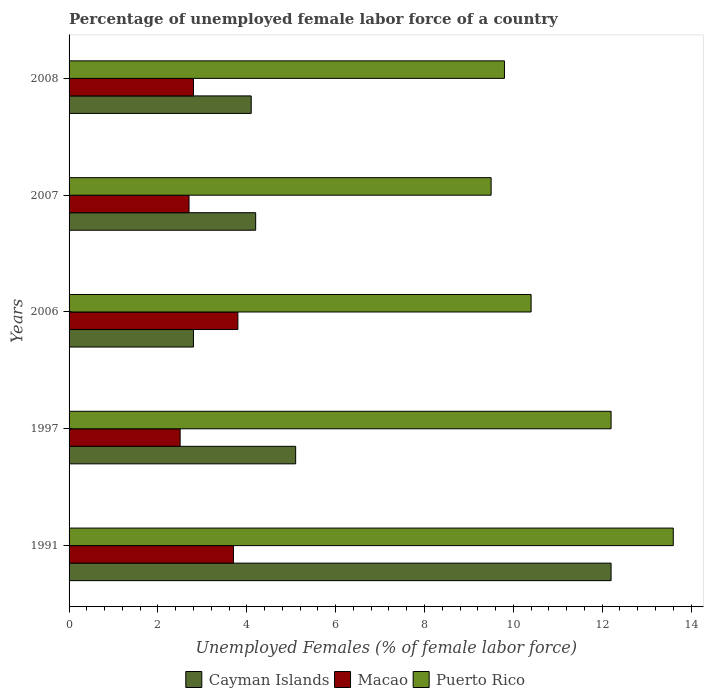How many different coloured bars are there?
Offer a very short reply. 3. How many groups of bars are there?
Offer a terse response. 5. Are the number of bars on each tick of the Y-axis equal?
Your answer should be very brief. Yes. How many bars are there on the 2nd tick from the top?
Offer a terse response. 3. What is the label of the 4th group of bars from the top?
Ensure brevity in your answer.  1997. What is the percentage of unemployed female labor force in Macao in 1991?
Offer a terse response. 3.7. Across all years, what is the maximum percentage of unemployed female labor force in Puerto Rico?
Offer a very short reply. 13.6. In which year was the percentage of unemployed female labor force in Macao minimum?
Give a very brief answer. 1997. What is the difference between the percentage of unemployed female labor force in Macao in 1997 and that in 2006?
Keep it short and to the point. -1.3. What is the difference between the percentage of unemployed female labor force in Macao in 2006 and the percentage of unemployed female labor force in Puerto Rico in 2007?
Ensure brevity in your answer.  -5.7. In the year 2006, what is the difference between the percentage of unemployed female labor force in Puerto Rico and percentage of unemployed female labor force in Cayman Islands?
Make the answer very short. 7.6. What is the ratio of the percentage of unemployed female labor force in Cayman Islands in 1991 to that in 2008?
Ensure brevity in your answer.  2.98. Is the percentage of unemployed female labor force in Cayman Islands in 1991 less than that in 2006?
Keep it short and to the point. No. Is the difference between the percentage of unemployed female labor force in Puerto Rico in 1997 and 2007 greater than the difference between the percentage of unemployed female labor force in Cayman Islands in 1997 and 2007?
Your answer should be compact. Yes. What is the difference between the highest and the second highest percentage of unemployed female labor force in Cayman Islands?
Your answer should be compact. 7.1. What is the difference between the highest and the lowest percentage of unemployed female labor force in Puerto Rico?
Give a very brief answer. 4.1. In how many years, is the percentage of unemployed female labor force in Macao greater than the average percentage of unemployed female labor force in Macao taken over all years?
Ensure brevity in your answer.  2. What does the 3rd bar from the top in 2006 represents?
Your answer should be compact. Cayman Islands. What does the 2nd bar from the bottom in 2008 represents?
Ensure brevity in your answer.  Macao. How many bars are there?
Your response must be concise. 15. Are all the bars in the graph horizontal?
Offer a very short reply. Yes. What is the difference between two consecutive major ticks on the X-axis?
Give a very brief answer. 2. Does the graph contain grids?
Give a very brief answer. No. How many legend labels are there?
Your response must be concise. 3. What is the title of the graph?
Ensure brevity in your answer.  Percentage of unemployed female labor force of a country. What is the label or title of the X-axis?
Offer a very short reply. Unemployed Females (% of female labor force). What is the Unemployed Females (% of female labor force) of Cayman Islands in 1991?
Provide a short and direct response. 12.2. What is the Unemployed Females (% of female labor force) of Macao in 1991?
Give a very brief answer. 3.7. What is the Unemployed Females (% of female labor force) of Puerto Rico in 1991?
Ensure brevity in your answer.  13.6. What is the Unemployed Females (% of female labor force) of Cayman Islands in 1997?
Your response must be concise. 5.1. What is the Unemployed Females (% of female labor force) in Puerto Rico in 1997?
Make the answer very short. 12.2. What is the Unemployed Females (% of female labor force) of Cayman Islands in 2006?
Keep it short and to the point. 2.8. What is the Unemployed Females (% of female labor force) of Macao in 2006?
Provide a succinct answer. 3.8. What is the Unemployed Females (% of female labor force) of Puerto Rico in 2006?
Keep it short and to the point. 10.4. What is the Unemployed Females (% of female labor force) of Cayman Islands in 2007?
Give a very brief answer. 4.2. What is the Unemployed Females (% of female labor force) in Macao in 2007?
Provide a short and direct response. 2.7. What is the Unemployed Females (% of female labor force) of Puerto Rico in 2007?
Make the answer very short. 9.5. What is the Unemployed Females (% of female labor force) in Cayman Islands in 2008?
Provide a short and direct response. 4.1. What is the Unemployed Females (% of female labor force) of Macao in 2008?
Give a very brief answer. 2.8. What is the Unemployed Females (% of female labor force) of Puerto Rico in 2008?
Keep it short and to the point. 9.8. Across all years, what is the maximum Unemployed Females (% of female labor force) of Cayman Islands?
Your response must be concise. 12.2. Across all years, what is the maximum Unemployed Females (% of female labor force) of Macao?
Your answer should be compact. 3.8. Across all years, what is the maximum Unemployed Females (% of female labor force) in Puerto Rico?
Provide a succinct answer. 13.6. Across all years, what is the minimum Unemployed Females (% of female labor force) of Cayman Islands?
Ensure brevity in your answer.  2.8. What is the total Unemployed Females (% of female labor force) of Cayman Islands in the graph?
Offer a very short reply. 28.4. What is the total Unemployed Females (% of female labor force) of Macao in the graph?
Your answer should be compact. 15.5. What is the total Unemployed Females (% of female labor force) in Puerto Rico in the graph?
Provide a short and direct response. 55.5. What is the difference between the Unemployed Females (% of female labor force) of Macao in 1991 and that in 1997?
Your response must be concise. 1.2. What is the difference between the Unemployed Females (% of female labor force) of Macao in 1991 and that in 2006?
Provide a short and direct response. -0.1. What is the difference between the Unemployed Females (% of female labor force) of Macao in 1991 and that in 2007?
Your answer should be very brief. 1. What is the difference between the Unemployed Females (% of female labor force) of Macao in 1991 and that in 2008?
Ensure brevity in your answer.  0.9. What is the difference between the Unemployed Females (% of female labor force) in Cayman Islands in 1997 and that in 2006?
Make the answer very short. 2.3. What is the difference between the Unemployed Females (% of female labor force) in Macao in 1997 and that in 2006?
Your response must be concise. -1.3. What is the difference between the Unemployed Females (% of female labor force) in Macao in 1997 and that in 2007?
Your answer should be compact. -0.2. What is the difference between the Unemployed Females (% of female labor force) of Cayman Islands in 1997 and that in 2008?
Make the answer very short. 1. What is the difference between the Unemployed Females (% of female labor force) in Macao in 1997 and that in 2008?
Make the answer very short. -0.3. What is the difference between the Unemployed Females (% of female labor force) in Macao in 2006 and that in 2007?
Give a very brief answer. 1.1. What is the difference between the Unemployed Females (% of female labor force) of Puerto Rico in 2006 and that in 2008?
Make the answer very short. 0.6. What is the difference between the Unemployed Females (% of female labor force) in Macao in 2007 and that in 2008?
Offer a very short reply. -0.1. What is the difference between the Unemployed Females (% of female labor force) of Puerto Rico in 2007 and that in 2008?
Your response must be concise. -0.3. What is the difference between the Unemployed Females (% of female labor force) in Cayman Islands in 1991 and the Unemployed Females (% of female labor force) in Macao in 1997?
Your answer should be compact. 9.7. What is the difference between the Unemployed Females (% of female labor force) in Cayman Islands in 1991 and the Unemployed Females (% of female labor force) in Puerto Rico in 1997?
Keep it short and to the point. 0. What is the difference between the Unemployed Females (% of female labor force) in Macao in 1991 and the Unemployed Females (% of female labor force) in Puerto Rico in 1997?
Ensure brevity in your answer.  -8.5. What is the difference between the Unemployed Females (% of female labor force) in Cayman Islands in 1991 and the Unemployed Females (% of female labor force) in Puerto Rico in 2006?
Keep it short and to the point. 1.8. What is the difference between the Unemployed Females (% of female labor force) in Cayman Islands in 1991 and the Unemployed Females (% of female labor force) in Macao in 2007?
Ensure brevity in your answer.  9.5. What is the difference between the Unemployed Females (% of female labor force) of Cayman Islands in 1991 and the Unemployed Females (% of female labor force) of Puerto Rico in 2007?
Make the answer very short. 2.7. What is the difference between the Unemployed Females (% of female labor force) in Macao in 1991 and the Unemployed Females (% of female labor force) in Puerto Rico in 2007?
Keep it short and to the point. -5.8. What is the difference between the Unemployed Females (% of female labor force) of Macao in 1997 and the Unemployed Females (% of female labor force) of Puerto Rico in 2008?
Keep it short and to the point. -7.3. What is the difference between the Unemployed Females (% of female labor force) in Cayman Islands in 2006 and the Unemployed Females (% of female labor force) in Macao in 2007?
Provide a short and direct response. 0.1. What is the difference between the Unemployed Females (% of female labor force) in Cayman Islands in 2006 and the Unemployed Females (% of female labor force) in Puerto Rico in 2008?
Make the answer very short. -7. What is the difference between the Unemployed Females (% of female labor force) in Cayman Islands in 2007 and the Unemployed Females (% of female labor force) in Macao in 2008?
Give a very brief answer. 1.4. What is the difference between the Unemployed Females (% of female labor force) in Cayman Islands in 2007 and the Unemployed Females (% of female labor force) in Puerto Rico in 2008?
Keep it short and to the point. -5.6. What is the difference between the Unemployed Females (% of female labor force) of Macao in 2007 and the Unemployed Females (% of female labor force) of Puerto Rico in 2008?
Your response must be concise. -7.1. What is the average Unemployed Females (% of female labor force) of Cayman Islands per year?
Keep it short and to the point. 5.68. What is the average Unemployed Females (% of female labor force) in Macao per year?
Offer a very short reply. 3.1. What is the average Unemployed Females (% of female labor force) of Puerto Rico per year?
Provide a short and direct response. 11.1. In the year 1991, what is the difference between the Unemployed Females (% of female labor force) in Cayman Islands and Unemployed Females (% of female labor force) in Puerto Rico?
Offer a terse response. -1.4. In the year 1997, what is the difference between the Unemployed Females (% of female labor force) in Cayman Islands and Unemployed Females (% of female labor force) in Puerto Rico?
Provide a short and direct response. -7.1. In the year 1997, what is the difference between the Unemployed Females (% of female labor force) in Macao and Unemployed Females (% of female labor force) in Puerto Rico?
Your answer should be compact. -9.7. In the year 2006, what is the difference between the Unemployed Females (% of female labor force) in Cayman Islands and Unemployed Females (% of female labor force) in Macao?
Ensure brevity in your answer.  -1. In the year 2006, what is the difference between the Unemployed Females (% of female labor force) of Cayman Islands and Unemployed Females (% of female labor force) of Puerto Rico?
Make the answer very short. -7.6. In the year 2007, what is the difference between the Unemployed Females (% of female labor force) in Macao and Unemployed Females (% of female labor force) in Puerto Rico?
Ensure brevity in your answer.  -6.8. What is the ratio of the Unemployed Females (% of female labor force) in Cayman Islands in 1991 to that in 1997?
Provide a succinct answer. 2.39. What is the ratio of the Unemployed Females (% of female labor force) of Macao in 1991 to that in 1997?
Your answer should be compact. 1.48. What is the ratio of the Unemployed Females (% of female labor force) of Puerto Rico in 1991 to that in 1997?
Offer a very short reply. 1.11. What is the ratio of the Unemployed Females (% of female labor force) in Cayman Islands in 1991 to that in 2006?
Your answer should be very brief. 4.36. What is the ratio of the Unemployed Females (% of female labor force) in Macao in 1991 to that in 2006?
Offer a very short reply. 0.97. What is the ratio of the Unemployed Females (% of female labor force) of Puerto Rico in 1991 to that in 2006?
Offer a terse response. 1.31. What is the ratio of the Unemployed Females (% of female labor force) of Cayman Islands in 1991 to that in 2007?
Offer a terse response. 2.9. What is the ratio of the Unemployed Females (% of female labor force) of Macao in 1991 to that in 2007?
Provide a short and direct response. 1.37. What is the ratio of the Unemployed Females (% of female labor force) in Puerto Rico in 1991 to that in 2007?
Make the answer very short. 1.43. What is the ratio of the Unemployed Females (% of female labor force) in Cayman Islands in 1991 to that in 2008?
Provide a short and direct response. 2.98. What is the ratio of the Unemployed Females (% of female labor force) of Macao in 1991 to that in 2008?
Your response must be concise. 1.32. What is the ratio of the Unemployed Females (% of female labor force) in Puerto Rico in 1991 to that in 2008?
Offer a very short reply. 1.39. What is the ratio of the Unemployed Females (% of female labor force) of Cayman Islands in 1997 to that in 2006?
Provide a short and direct response. 1.82. What is the ratio of the Unemployed Females (% of female labor force) of Macao in 1997 to that in 2006?
Your answer should be compact. 0.66. What is the ratio of the Unemployed Females (% of female labor force) of Puerto Rico in 1997 to that in 2006?
Your response must be concise. 1.17. What is the ratio of the Unemployed Females (% of female labor force) of Cayman Islands in 1997 to that in 2007?
Your answer should be compact. 1.21. What is the ratio of the Unemployed Females (% of female labor force) of Macao in 1997 to that in 2007?
Make the answer very short. 0.93. What is the ratio of the Unemployed Females (% of female labor force) of Puerto Rico in 1997 to that in 2007?
Keep it short and to the point. 1.28. What is the ratio of the Unemployed Females (% of female labor force) in Cayman Islands in 1997 to that in 2008?
Ensure brevity in your answer.  1.24. What is the ratio of the Unemployed Females (% of female labor force) in Macao in 1997 to that in 2008?
Your answer should be compact. 0.89. What is the ratio of the Unemployed Females (% of female labor force) of Puerto Rico in 1997 to that in 2008?
Your response must be concise. 1.24. What is the ratio of the Unemployed Females (% of female labor force) of Macao in 2006 to that in 2007?
Give a very brief answer. 1.41. What is the ratio of the Unemployed Females (% of female labor force) in Puerto Rico in 2006 to that in 2007?
Your response must be concise. 1.09. What is the ratio of the Unemployed Females (% of female labor force) of Cayman Islands in 2006 to that in 2008?
Keep it short and to the point. 0.68. What is the ratio of the Unemployed Females (% of female labor force) in Macao in 2006 to that in 2008?
Provide a succinct answer. 1.36. What is the ratio of the Unemployed Females (% of female labor force) in Puerto Rico in 2006 to that in 2008?
Give a very brief answer. 1.06. What is the ratio of the Unemployed Females (% of female labor force) of Cayman Islands in 2007 to that in 2008?
Give a very brief answer. 1.02. What is the ratio of the Unemployed Females (% of female labor force) in Macao in 2007 to that in 2008?
Your answer should be compact. 0.96. What is the ratio of the Unemployed Females (% of female labor force) in Puerto Rico in 2007 to that in 2008?
Offer a terse response. 0.97. What is the difference between the highest and the lowest Unemployed Females (% of female labor force) of Macao?
Keep it short and to the point. 1.3. 